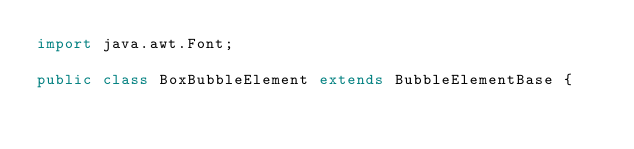Convert code to text. <code><loc_0><loc_0><loc_500><loc_500><_Java_>import java.awt.Font;

public class BoxBubbleElement extends BubbleElementBase {</code> 